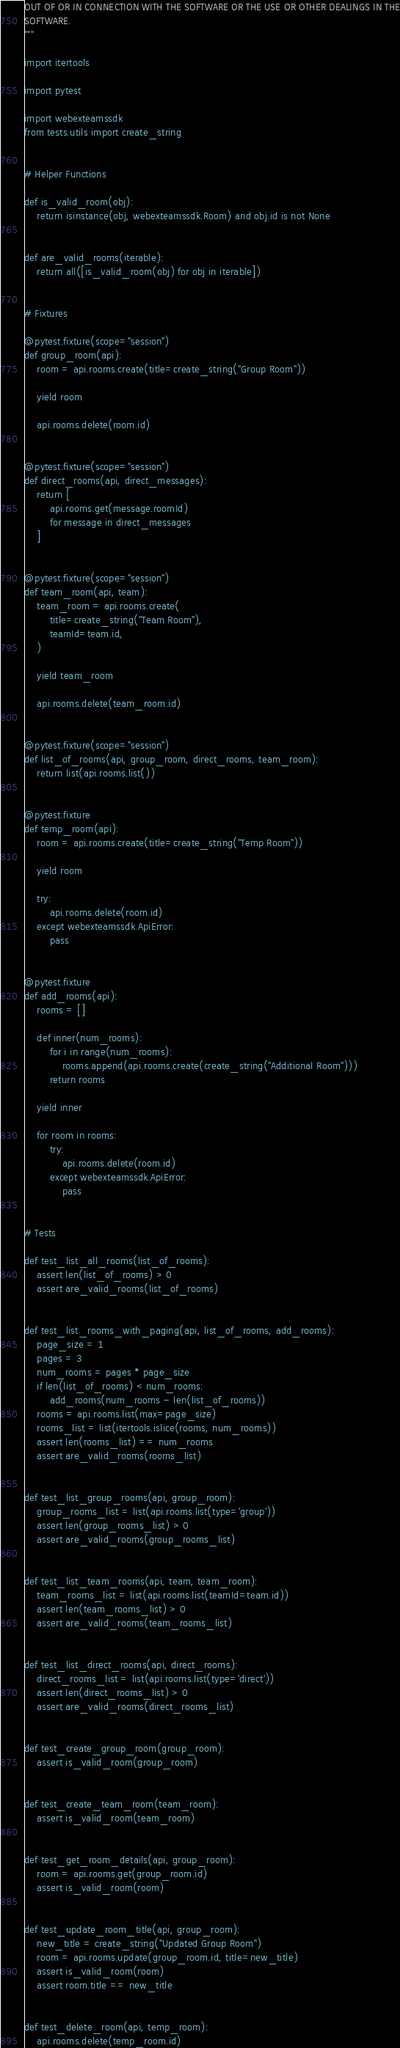<code> <loc_0><loc_0><loc_500><loc_500><_Python_>OUT OF OR IN CONNECTION WITH THE SOFTWARE OR THE USE OR OTHER DEALINGS IN THE
SOFTWARE.
"""

import itertools

import pytest

import webexteamssdk
from tests.utils import create_string


# Helper Functions

def is_valid_room(obj):
    return isinstance(obj, webexteamssdk.Room) and obj.id is not None


def are_valid_rooms(iterable):
    return all([is_valid_room(obj) for obj in iterable])


# Fixtures

@pytest.fixture(scope="session")
def group_room(api):
    room = api.rooms.create(title=create_string("Group Room"))

    yield room

    api.rooms.delete(room.id)


@pytest.fixture(scope="session")
def direct_rooms(api, direct_messages):
    return [
        api.rooms.get(message.roomId)
        for message in direct_messages
    ]


@pytest.fixture(scope="session")
def team_room(api, team):
    team_room = api.rooms.create(
        title=create_string("Team Room"),
        teamId=team.id,
    )

    yield team_room

    api.rooms.delete(team_room.id)


@pytest.fixture(scope="session")
def list_of_rooms(api, group_room, direct_rooms, team_room):
    return list(api.rooms.list())


@pytest.fixture
def temp_room(api):
    room = api.rooms.create(title=create_string("Temp Room"))

    yield room

    try:
        api.rooms.delete(room.id)
    except webexteamssdk.ApiError:
        pass


@pytest.fixture
def add_rooms(api):
    rooms = []

    def inner(num_rooms):
        for i in range(num_rooms):
            rooms.append(api.rooms.create(create_string("Additional Room")))
        return rooms

    yield inner

    for room in rooms:
        try:
            api.rooms.delete(room.id)
        except webexteamssdk.ApiError:
            pass


# Tests

def test_list_all_rooms(list_of_rooms):
    assert len(list_of_rooms) > 0
    assert are_valid_rooms(list_of_rooms)


def test_list_rooms_with_paging(api, list_of_rooms, add_rooms):
    page_size = 1
    pages = 3
    num_rooms = pages * page_size
    if len(list_of_rooms) < num_rooms:
        add_rooms(num_rooms - len(list_of_rooms))
    rooms = api.rooms.list(max=page_size)
    rooms_list = list(itertools.islice(rooms, num_rooms))
    assert len(rooms_list) == num_rooms
    assert are_valid_rooms(rooms_list)


def test_list_group_rooms(api, group_room):
    group_rooms_list = list(api.rooms.list(type='group'))
    assert len(group_rooms_list) > 0
    assert are_valid_rooms(group_rooms_list)


def test_list_team_rooms(api, team, team_room):
    team_rooms_list = list(api.rooms.list(teamId=team.id))
    assert len(team_rooms_list) > 0
    assert are_valid_rooms(team_rooms_list)


def test_list_direct_rooms(api, direct_rooms):
    direct_rooms_list = list(api.rooms.list(type='direct'))
    assert len(direct_rooms_list) > 0
    assert are_valid_rooms(direct_rooms_list)


def test_create_group_room(group_room):
    assert is_valid_room(group_room)


def test_create_team_room(team_room):
    assert is_valid_room(team_room)


def test_get_room_details(api, group_room):
    room = api.rooms.get(group_room.id)
    assert is_valid_room(room)


def test_update_room_title(api, group_room):
    new_title = create_string("Updated Group Room")
    room = api.rooms.update(group_room.id, title=new_title)
    assert is_valid_room(room)
    assert room.title == new_title


def test_delete_room(api, temp_room):
    api.rooms.delete(temp_room.id)
</code> 